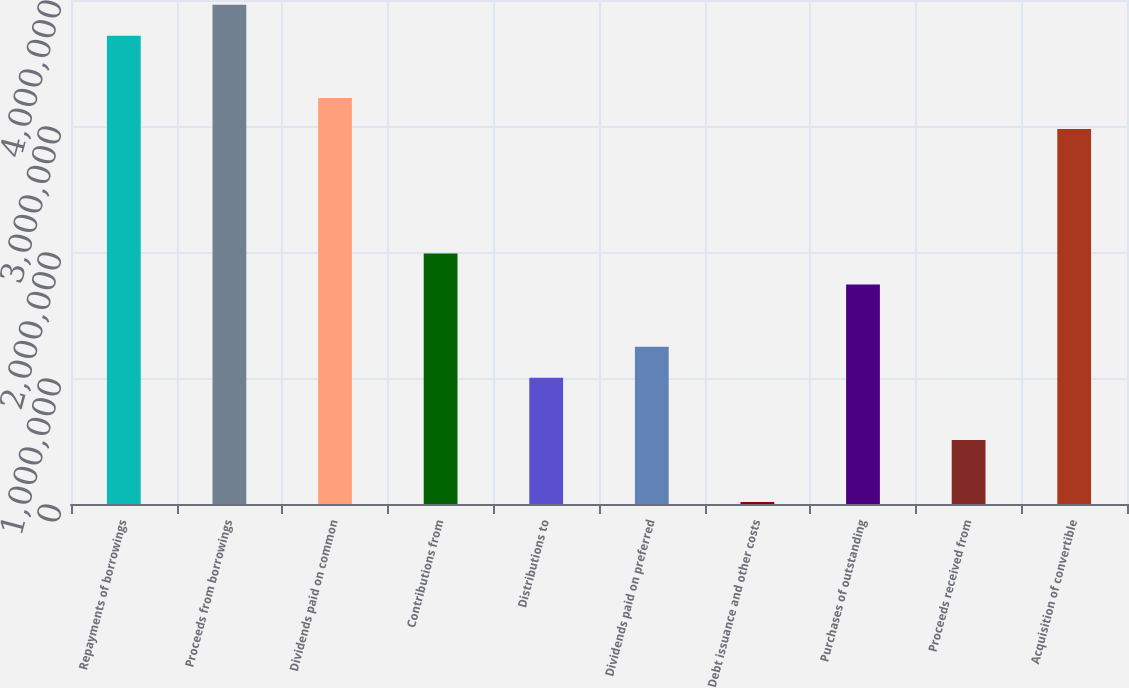<chart> <loc_0><loc_0><loc_500><loc_500><bar_chart><fcel>Repayments of borrowings<fcel>Proceeds from borrowings<fcel>Dividends paid on common<fcel>Contributions from<fcel>Distributions to<fcel>Dividends paid on preferred<fcel>Debt issuance and other costs<fcel>Purchases of outstanding<fcel>Proceeds received from<fcel>Acquisition of convertible<nl><fcel>3.71533e+06<fcel>3.96202e+06<fcel>3.22195e+06<fcel>1.9885e+06<fcel>1.00174e+06<fcel>1.24843e+06<fcel>14980<fcel>1.74181e+06<fcel>508361<fcel>2.97526e+06<nl></chart> 